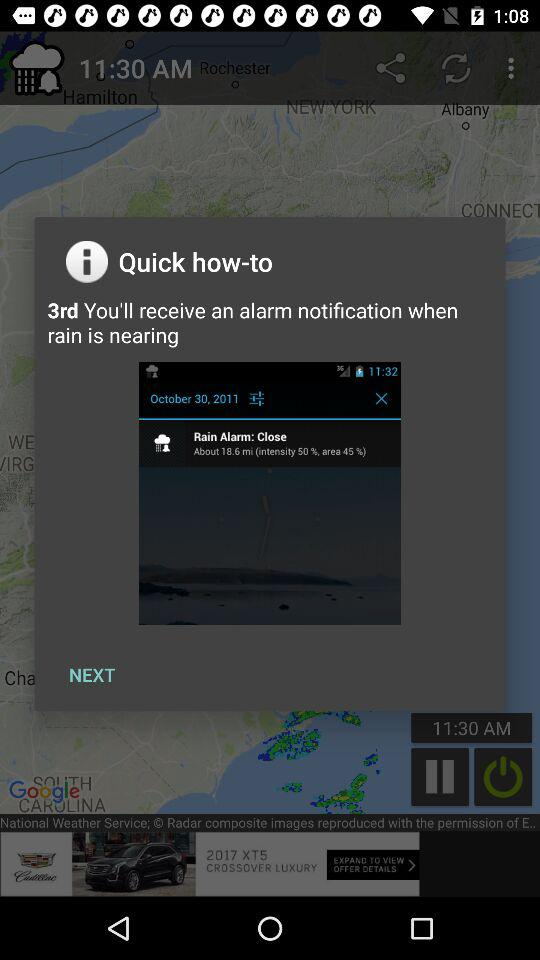What is the predicted date of the rain? The predicted date of the rain is October 30, 2011. 